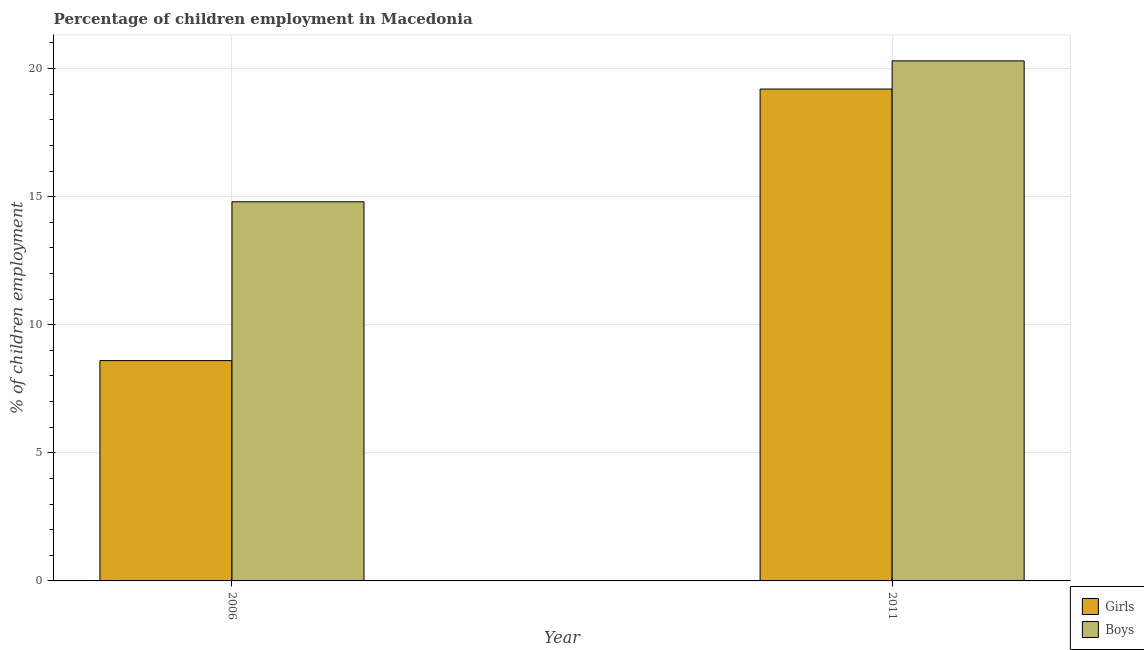Are the number of bars per tick equal to the number of legend labels?
Give a very brief answer. Yes. How many bars are there on the 1st tick from the right?
Give a very brief answer. 2. In which year was the percentage of employed girls maximum?
Ensure brevity in your answer.  2011. What is the total percentage of employed boys in the graph?
Provide a succinct answer. 35.1. What is the average percentage of employed girls per year?
Your answer should be very brief. 13.9. In the year 2011, what is the difference between the percentage of employed girls and percentage of employed boys?
Make the answer very short. 0. What is the ratio of the percentage of employed girls in 2006 to that in 2011?
Ensure brevity in your answer.  0.45. In how many years, is the percentage of employed girls greater than the average percentage of employed girls taken over all years?
Ensure brevity in your answer.  1. What does the 1st bar from the left in 2006 represents?
Your response must be concise. Girls. What does the 2nd bar from the right in 2006 represents?
Your response must be concise. Girls. How many bars are there?
Ensure brevity in your answer.  4. Are all the bars in the graph horizontal?
Give a very brief answer. No. What is the difference between two consecutive major ticks on the Y-axis?
Ensure brevity in your answer.  5. Where does the legend appear in the graph?
Your response must be concise. Bottom right. How many legend labels are there?
Your answer should be very brief. 2. How are the legend labels stacked?
Keep it short and to the point. Vertical. What is the title of the graph?
Ensure brevity in your answer.  Percentage of children employment in Macedonia. What is the label or title of the Y-axis?
Ensure brevity in your answer.  % of children employment. What is the % of children employment of Girls in 2006?
Offer a very short reply. 8.6. What is the % of children employment in Boys in 2006?
Your answer should be compact. 14.8. What is the % of children employment of Boys in 2011?
Your answer should be compact. 20.3. Across all years, what is the maximum % of children employment in Boys?
Ensure brevity in your answer.  20.3. What is the total % of children employment in Girls in the graph?
Your answer should be compact. 27.8. What is the total % of children employment of Boys in the graph?
Ensure brevity in your answer.  35.1. What is the difference between the % of children employment in Girls in 2006 and that in 2011?
Make the answer very short. -10.6. What is the difference between the % of children employment in Girls in 2006 and the % of children employment in Boys in 2011?
Give a very brief answer. -11.7. What is the average % of children employment in Boys per year?
Your answer should be compact. 17.55. In the year 2011, what is the difference between the % of children employment of Girls and % of children employment of Boys?
Keep it short and to the point. -1.1. What is the ratio of the % of children employment in Girls in 2006 to that in 2011?
Provide a succinct answer. 0.45. What is the ratio of the % of children employment in Boys in 2006 to that in 2011?
Keep it short and to the point. 0.73. What is the difference between the highest and the second highest % of children employment in Girls?
Give a very brief answer. 10.6. What is the difference between the highest and the second highest % of children employment of Boys?
Keep it short and to the point. 5.5. 